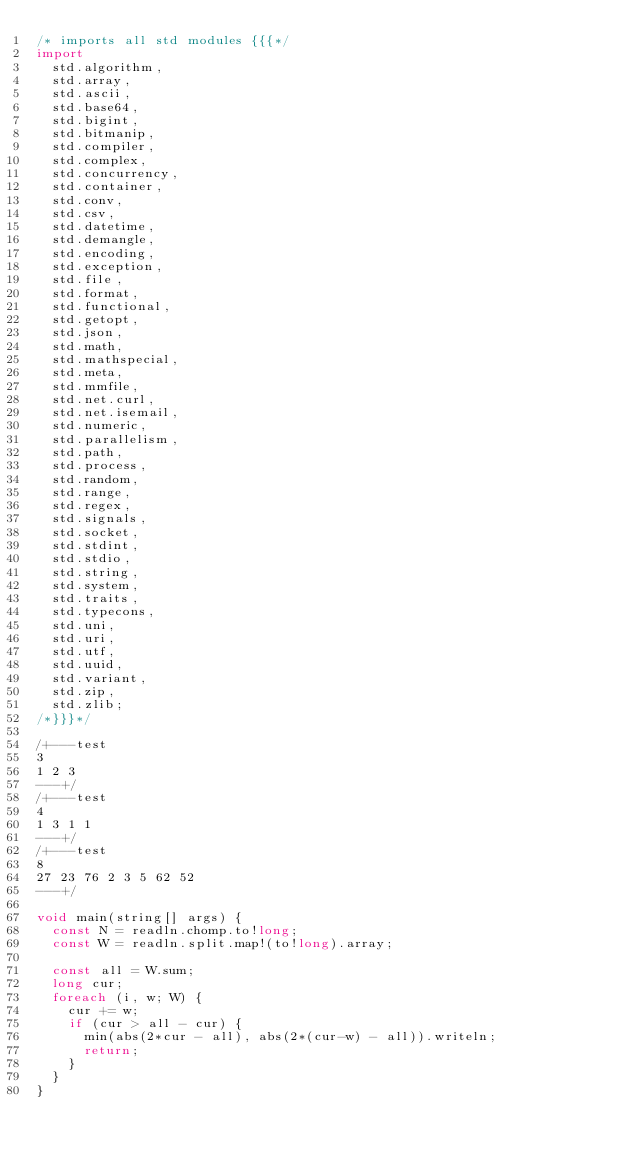Convert code to text. <code><loc_0><loc_0><loc_500><loc_500><_D_>/* imports all std modules {{{*/
import
  std.algorithm,
  std.array,
  std.ascii,
  std.base64,
  std.bigint,
  std.bitmanip,
  std.compiler,
  std.complex,
  std.concurrency,
  std.container,
  std.conv,
  std.csv,
  std.datetime,
  std.demangle,
  std.encoding,
  std.exception,
  std.file,
  std.format,
  std.functional,
  std.getopt,
  std.json,
  std.math,
  std.mathspecial,
  std.meta,
  std.mmfile,
  std.net.curl,
  std.net.isemail,
  std.numeric,
  std.parallelism,
  std.path,
  std.process,
  std.random,
  std.range,
  std.regex,
  std.signals,
  std.socket,
  std.stdint,
  std.stdio,
  std.string,
  std.system,
  std.traits,
  std.typecons,
  std.uni,
  std.uri,
  std.utf,
  std.uuid,
  std.variant,
  std.zip,
  std.zlib;
/*}}}*/

/+---test
3
1 2 3
---+/
/+---test
4
1 3 1 1
---+/
/+---test
8
27 23 76 2 3 5 62 52
---+/

void main(string[] args) {
  const N = readln.chomp.to!long;
  const W = readln.split.map!(to!long).array;

  const all = W.sum;
  long cur;
  foreach (i, w; W) {
    cur += w;
    if (cur > all - cur) {
      min(abs(2*cur - all), abs(2*(cur-w) - all)).writeln;
      return;
    }
  }
}
</code> 